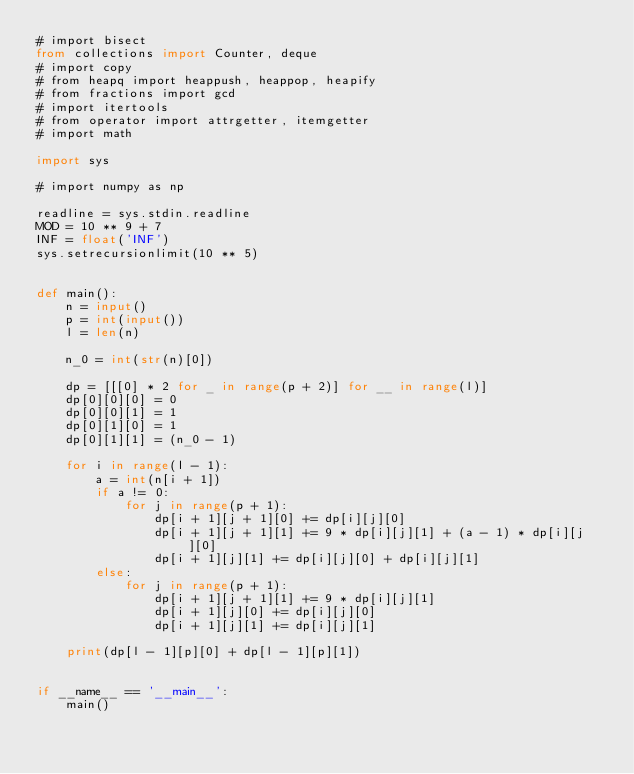<code> <loc_0><loc_0><loc_500><loc_500><_Python_># import bisect
from collections import Counter, deque
# import copy
# from heapq import heappush, heappop, heapify
# from fractions import gcd
# import itertools
# from operator import attrgetter, itemgetter
# import math

import sys

# import numpy as np

readline = sys.stdin.readline
MOD = 10 ** 9 + 7
INF = float('INF')
sys.setrecursionlimit(10 ** 5)


def main():
    n = input()
    p = int(input())
    l = len(n)

    n_0 = int(str(n)[0])

    dp = [[[0] * 2 for _ in range(p + 2)] for __ in range(l)]
    dp[0][0][0] = 0
    dp[0][0][1] = 1
    dp[0][1][0] = 1
    dp[0][1][1] = (n_0 - 1)

    for i in range(l - 1):
        a = int(n[i + 1])
        if a != 0:
            for j in range(p + 1):
                dp[i + 1][j + 1][0] += dp[i][j][0]
                dp[i + 1][j + 1][1] += 9 * dp[i][j][1] + (a - 1) * dp[i][j][0]
                dp[i + 1][j][1] += dp[i][j][0] + dp[i][j][1]
        else:
            for j in range(p + 1):
                dp[i + 1][j + 1][1] += 9 * dp[i][j][1]
                dp[i + 1][j][0] += dp[i][j][0]
                dp[i + 1][j][1] += dp[i][j][1]

    print(dp[l - 1][p][0] + dp[l - 1][p][1])


if __name__ == '__main__':
    main()
</code> 